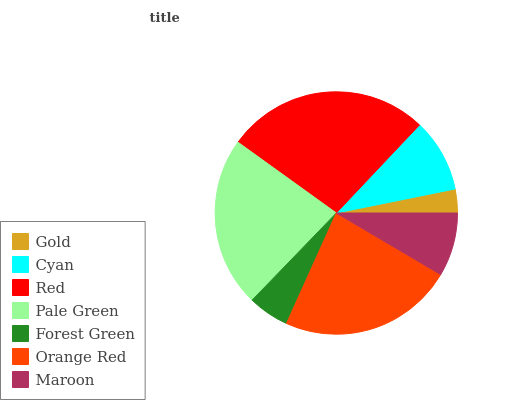Is Gold the minimum?
Answer yes or no. Yes. Is Red the maximum?
Answer yes or no. Yes. Is Cyan the minimum?
Answer yes or no. No. Is Cyan the maximum?
Answer yes or no. No. Is Cyan greater than Gold?
Answer yes or no. Yes. Is Gold less than Cyan?
Answer yes or no. Yes. Is Gold greater than Cyan?
Answer yes or no. No. Is Cyan less than Gold?
Answer yes or no. No. Is Cyan the high median?
Answer yes or no. Yes. Is Cyan the low median?
Answer yes or no. Yes. Is Orange Red the high median?
Answer yes or no. No. Is Pale Green the low median?
Answer yes or no. No. 